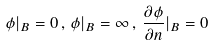<formula> <loc_0><loc_0><loc_500><loc_500>\phi | _ { B } = 0 \, , \, \phi | _ { B } = \infty \, , \, \frac { \partial \phi } { \partial n } | _ { B } = 0</formula> 